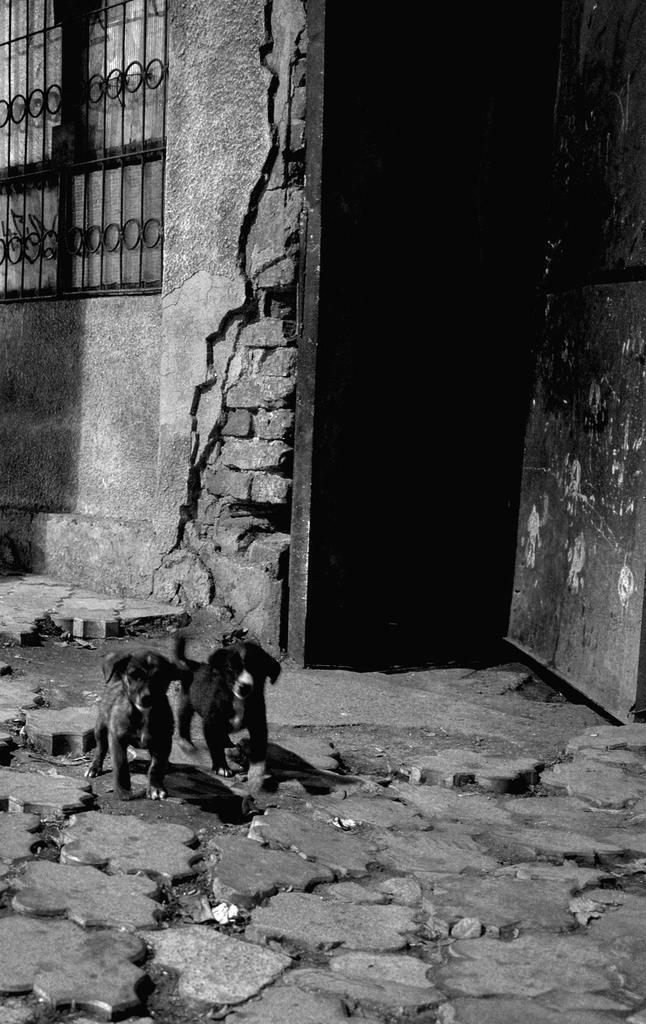How would you summarize this image in a sentence or two? In this image I can see two animals. To the side of these animals I can see the railing and the wall. 